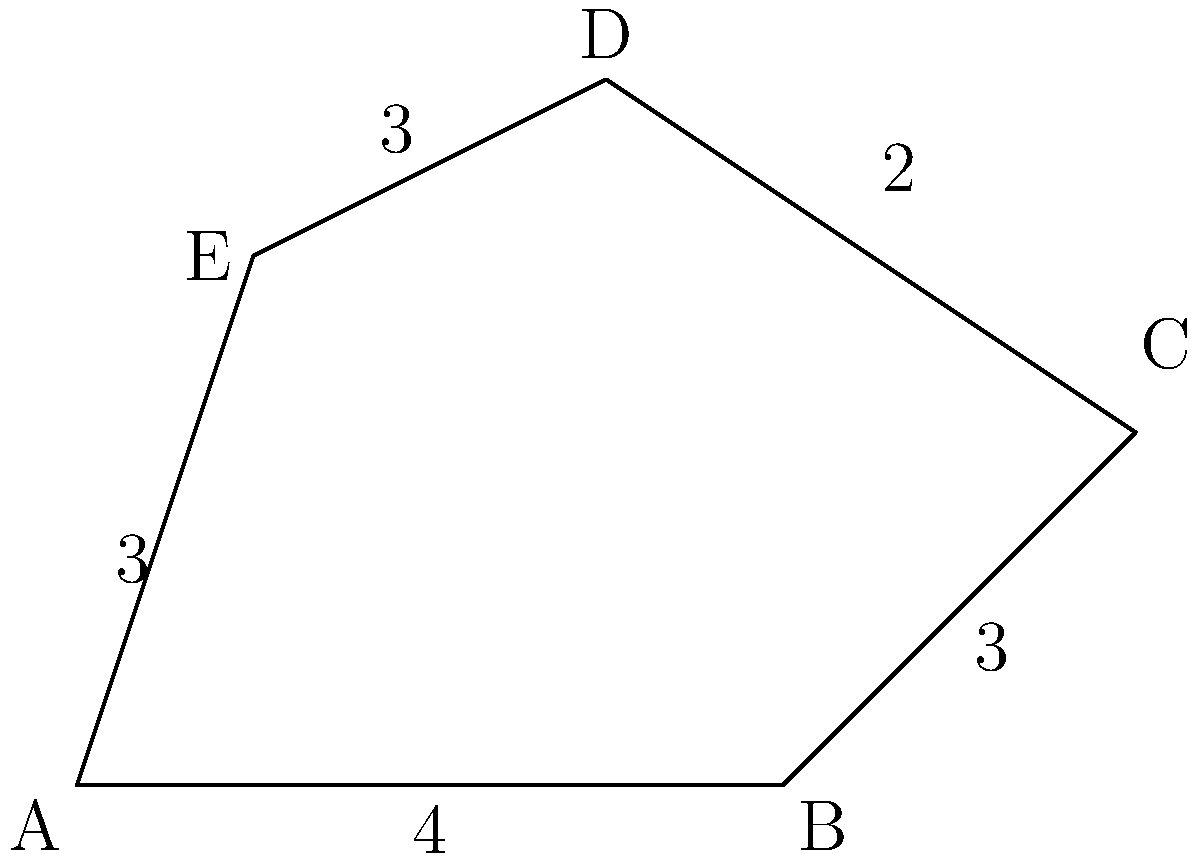In your 2D game level, you have an irregular polygon representing a platform. The coordinates of its vertices are A(0,0), B(4,0), C(6,2), D(3,4), and E(1,3). Calculate the area of this platform using the shoelace formula. Round your answer to two decimal places. To calculate the area of an irregular polygon using the shoelace formula, we can follow these steps:

1. List the coordinates of the vertices in order (clockwise or counterclockwise):
   (x1, y1), (x2, y2), (x3, y3), (x4, y4), (x5, y5)

2. Apply the shoelace formula:
   Area = $\frac{1}{2}|((x1y2 + x2y3 + x3y4 + x4y5 + x5y1) - (y1x2 + y2x3 + y3x4 + y4x5 + y5x1))|$

3. Substitute the given coordinates:
   (0,0), (4,0), (6,2), (3,4), (1,3)

4. Calculate:
   Area = $\frac{1}{2}|((0 \cdot 0 + 4 \cdot 2 + 6 \cdot 4 + 3 \cdot 3 + 1 \cdot 0) - (0 \cdot 4 + 0 \cdot 6 + 2 \cdot 3 + 4 \cdot 1 + 3 \cdot 0))|$
        = $\frac{1}{2}|((0 + 8 + 24 + 9 + 0) - (0 + 0 + 6 + 4 + 0))|$
        = $\frac{1}{2}|(41 - 10)|$
        = $\frac{1}{2} \cdot 31$
        = 15.5

5. Round to two decimal places: 15.50

Therefore, the area of the irregular polygon platform is 15.50 square units.
Answer: 15.50 square units 